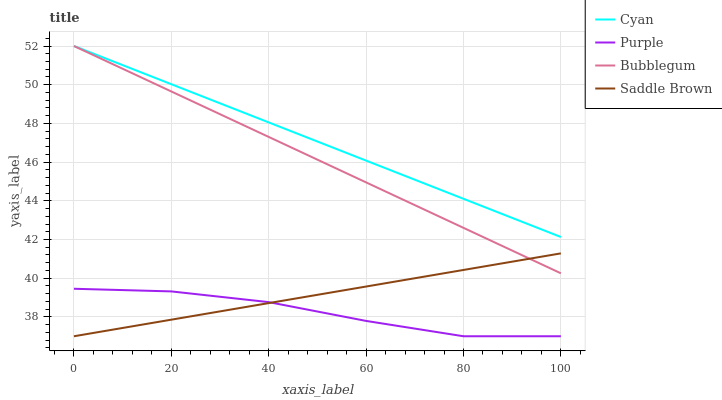Does Purple have the minimum area under the curve?
Answer yes or no. Yes. Does Cyan have the maximum area under the curve?
Answer yes or no. Yes. Does Saddle Brown have the minimum area under the curve?
Answer yes or no. No. Does Saddle Brown have the maximum area under the curve?
Answer yes or no. No. Is Cyan the smoothest?
Answer yes or no. Yes. Is Purple the roughest?
Answer yes or no. Yes. Is Saddle Brown the smoothest?
Answer yes or no. No. Is Saddle Brown the roughest?
Answer yes or no. No. Does Purple have the lowest value?
Answer yes or no. Yes. Does Cyan have the lowest value?
Answer yes or no. No. Does Bubblegum have the highest value?
Answer yes or no. Yes. Does Saddle Brown have the highest value?
Answer yes or no. No. Is Purple less than Cyan?
Answer yes or no. Yes. Is Cyan greater than Saddle Brown?
Answer yes or no. Yes. Does Saddle Brown intersect Purple?
Answer yes or no. Yes. Is Saddle Brown less than Purple?
Answer yes or no. No. Is Saddle Brown greater than Purple?
Answer yes or no. No. Does Purple intersect Cyan?
Answer yes or no. No. 